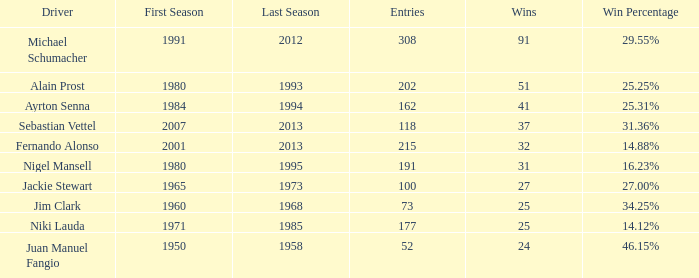Which driver has less than 37 wins and at 14.12%? 177.0. 